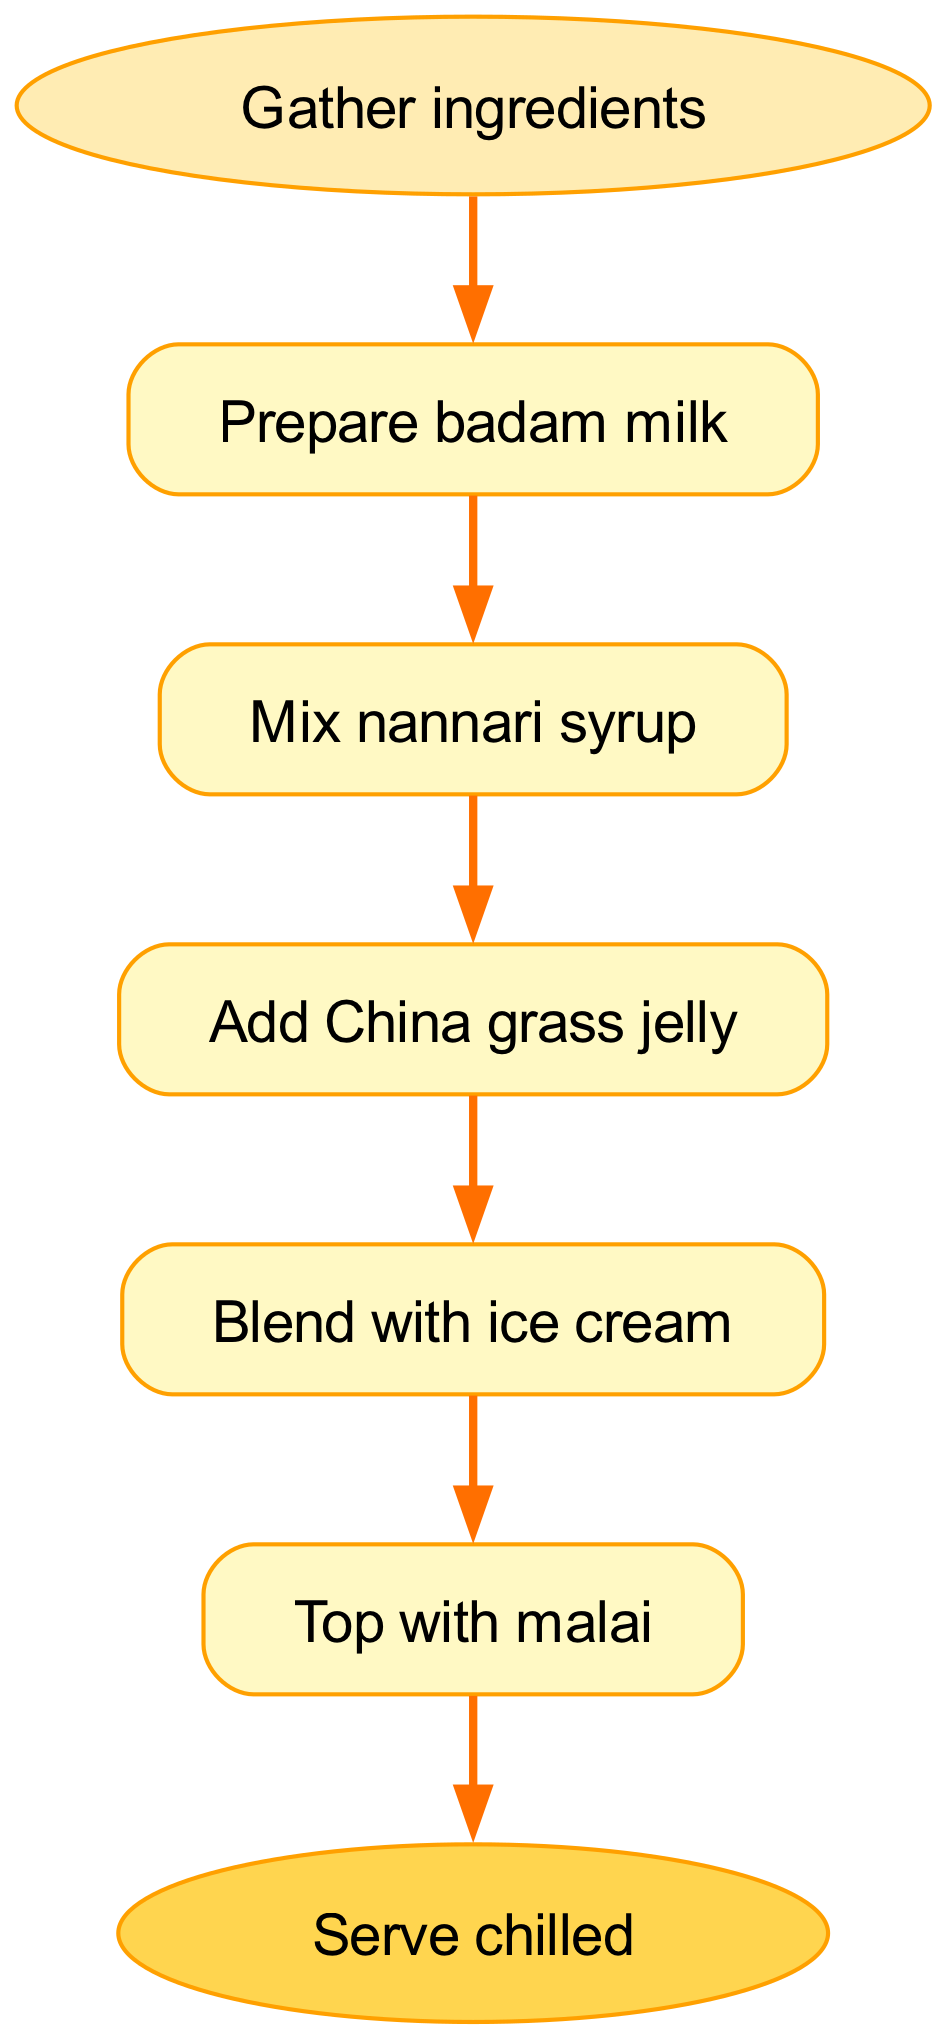What is the first step in making Jigarthanda? The first step in the flowchart is represented by the node labeled "Gather ingredients." This is where the preparation begins, implying all necessary ingredients should be collected.
Answer: Gather ingredients How many steps are there in total in the flowchart? The flowchart lists a total of six steps, starting from "Gather ingredients" and ending at "Serve chilled," including all the intermediary steps.
Answer: Six What comes after preparing badam milk? According to the flowchart, the step that follows "Prepare badam milk" is "Mix nannari syrup." This shows the sequence of preparation in which the nannari syrup is combined with the badam milk.
Answer: Mix nannari syrup Which ingredient is added after China grass jelly? The next step after "Add China grass jelly" is "Blend with ice cream." This indicates that the process continues by incorporating the ice cream after the jelly is added.
Answer: Blend with ice cream What is the final step before serving? The last action before serving the dish is topping it with malai, making it a key final touch in the preparation process, as indicated by the flow from the last processing step to the end.
Answer: Top with malai What is the shape used for the start and end nodes in the diagram? The start and end nodes are depicted as ovals in the flowchart. This shape differentiates the starting and ending points from other steps in the preparation process.
Answer: Oval How are the steps connected in the diagram? The steps are connected through directed edges, which indicate the sequence of actions to be taken across the preparation of Jigarthanda, illustrating a clear flow from one step to the next.
Answer: Directed edges What is the output of the last step? The last step, labeled "Serve chilled," provides the output of the entire process, indicating that the Jigarthanda should be served at a chilled temperature for enjoyment.
Answer: Serve chilled 